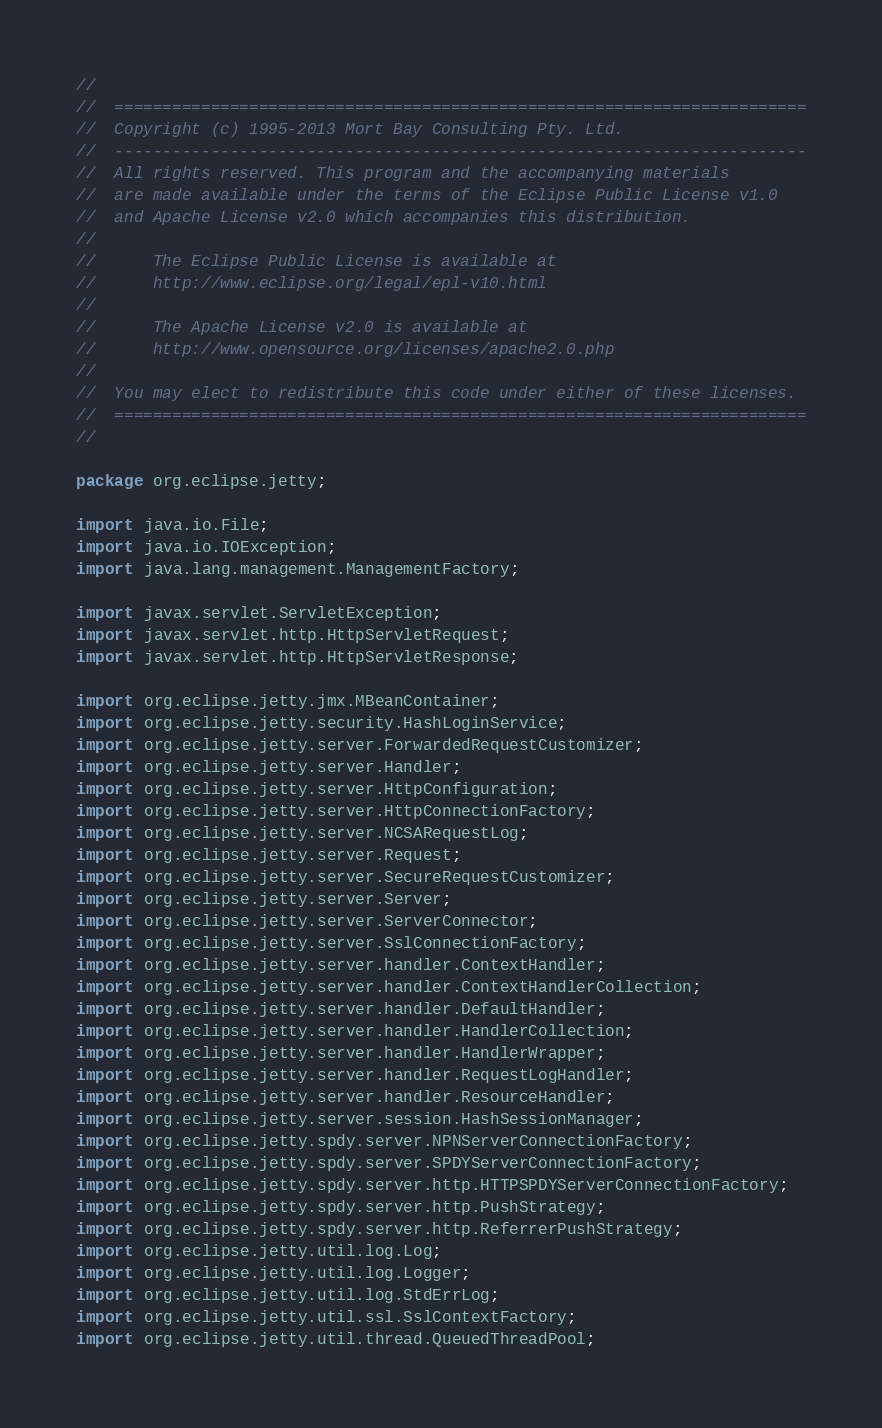Convert code to text. <code><loc_0><loc_0><loc_500><loc_500><_Java_>//
//  ========================================================================
//  Copyright (c) 1995-2013 Mort Bay Consulting Pty. Ltd.
//  ------------------------------------------------------------------------
//  All rights reserved. This program and the accompanying materials
//  are made available under the terms of the Eclipse Public License v1.0
//  and Apache License v2.0 which accompanies this distribution.
//
//      The Eclipse Public License is available at
//      http://www.eclipse.org/legal/epl-v10.html
//
//      The Apache License v2.0 is available at
//      http://www.opensource.org/licenses/apache2.0.php
//
//  You may elect to redistribute this code under either of these licenses.
//  ========================================================================
//

package org.eclipse.jetty;

import java.io.File;
import java.io.IOException;
import java.lang.management.ManagementFactory;

import javax.servlet.ServletException;
import javax.servlet.http.HttpServletRequest;
import javax.servlet.http.HttpServletResponse;

import org.eclipse.jetty.jmx.MBeanContainer;
import org.eclipse.jetty.security.HashLoginService;
import org.eclipse.jetty.server.ForwardedRequestCustomizer;
import org.eclipse.jetty.server.Handler;
import org.eclipse.jetty.server.HttpConfiguration;
import org.eclipse.jetty.server.HttpConnectionFactory;
import org.eclipse.jetty.server.NCSARequestLog;
import org.eclipse.jetty.server.Request;
import org.eclipse.jetty.server.SecureRequestCustomizer;
import org.eclipse.jetty.server.Server;
import org.eclipse.jetty.server.ServerConnector;
import org.eclipse.jetty.server.SslConnectionFactory;
import org.eclipse.jetty.server.handler.ContextHandler;
import org.eclipse.jetty.server.handler.ContextHandlerCollection;
import org.eclipse.jetty.server.handler.DefaultHandler;
import org.eclipse.jetty.server.handler.HandlerCollection;
import org.eclipse.jetty.server.handler.HandlerWrapper;
import org.eclipse.jetty.server.handler.RequestLogHandler;
import org.eclipse.jetty.server.handler.ResourceHandler;
import org.eclipse.jetty.server.session.HashSessionManager;
import org.eclipse.jetty.spdy.server.NPNServerConnectionFactory;
import org.eclipse.jetty.spdy.server.SPDYServerConnectionFactory;
import org.eclipse.jetty.spdy.server.http.HTTPSPDYServerConnectionFactory;
import org.eclipse.jetty.spdy.server.http.PushStrategy;
import org.eclipse.jetty.spdy.server.http.ReferrerPushStrategy;
import org.eclipse.jetty.util.log.Log;
import org.eclipse.jetty.util.log.Logger;
import org.eclipse.jetty.util.log.StdErrLog;
import org.eclipse.jetty.util.ssl.SslContextFactory;
import org.eclipse.jetty.util.thread.QueuedThreadPool;</code> 